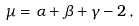Convert formula to latex. <formula><loc_0><loc_0><loc_500><loc_500>\mu = \alpha + \beta + \gamma - 2 \, ,</formula> 